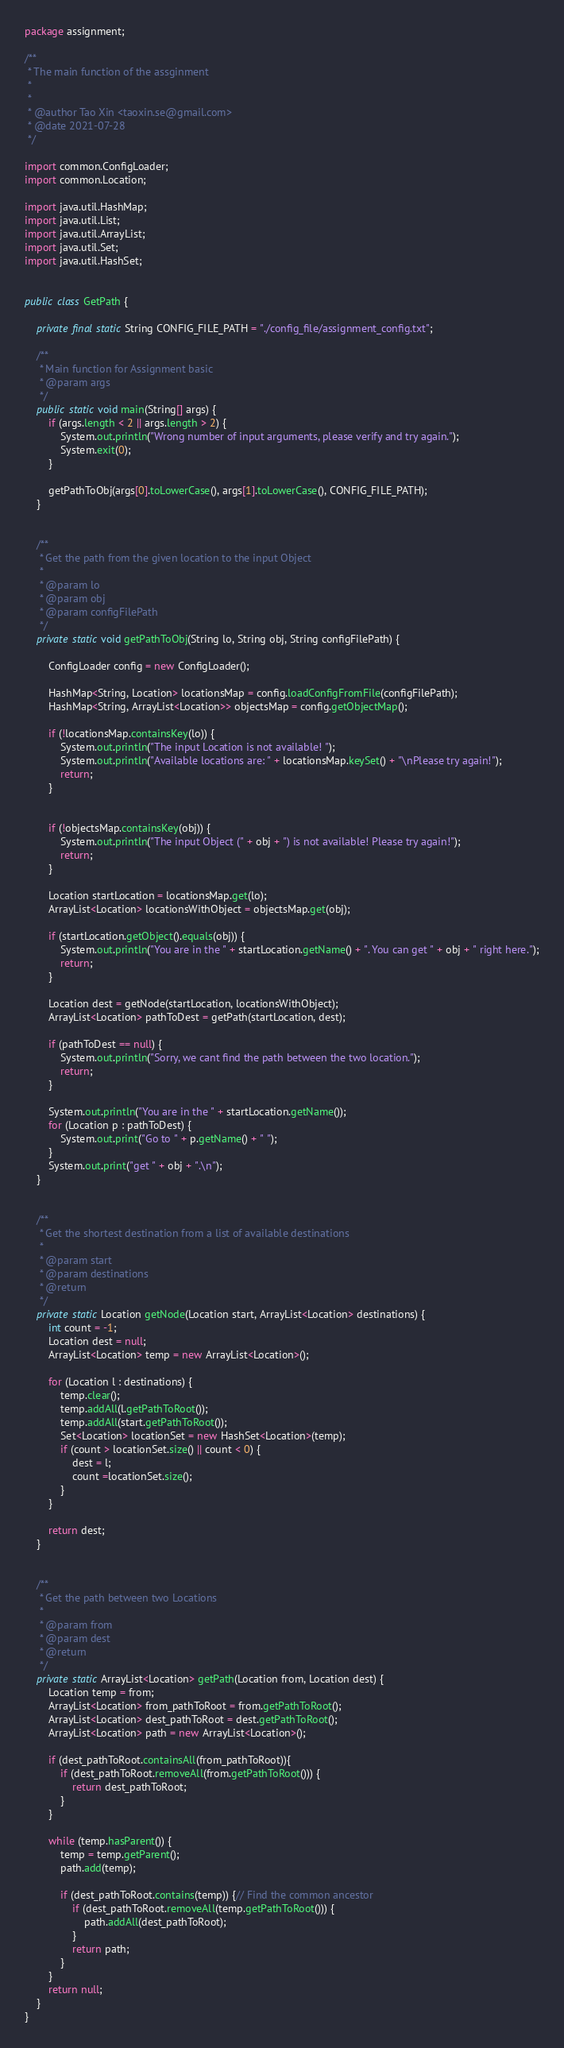<code> <loc_0><loc_0><loc_500><loc_500><_Java_>package assignment;

/**
 * The main function of the assginment
 *
 *
 * @author Tao Xin <taoxin.se@gmail.com>
 * @date 2021-07-28
 */

import common.ConfigLoader;
import common.Location;

import java.util.HashMap;
import java.util.List;
import java.util.ArrayList;
import java.util.Set;
import java.util.HashSet;


public class GetPath {

    private final static String CONFIG_FILE_PATH = "./config_file/assignment_config.txt";

    /**
     * Main function for Assignment basic
     * @param args
     */
    public static void main(String[] args) {
        if (args.length < 2 || args.length > 2) {
            System.out.println("Wrong number of input arguments, please verify and try again.");
            System.exit(0);
        }

        getPathToObj(args[0].toLowerCase(), args[1].toLowerCase(), CONFIG_FILE_PATH);
    }


    /**
     * Get the path from the given location to the input Object
     *
     * @param lo
     * @param obj
     * @param configFilePath
     */
    private static void getPathToObj(String lo, String obj, String configFilePath) {

        ConfigLoader config = new ConfigLoader();

        HashMap<String, Location> locationsMap = config.loadConfigFromFile(configFilePath);
        HashMap<String, ArrayList<Location>> objectsMap = config.getObjectMap();

        if (!locationsMap.containsKey(lo)) {
            System.out.println("The input Location is not available! ");
            System.out.println("Available locations are: " + locationsMap.keySet() + "\nPlease try again!");
            return;
        }


        if (!objectsMap.containsKey(obj)) {
            System.out.println("The input Object (" + obj + ") is not available! Please try again!");
            return;
        }

        Location startLocation = locationsMap.get(lo);
        ArrayList<Location> locationsWithObject = objectsMap.get(obj);

        if (startLocation.getObject().equals(obj)) {
            System.out.println("You are in the " + startLocation.getName() + ". You can get " + obj + " right here.");
            return;
        }

        Location dest = getNode(startLocation, locationsWithObject);
        ArrayList<Location> pathToDest = getPath(startLocation, dest);

        if (pathToDest == null) {
            System.out.println("Sorry, we cant find the path between the two location.");
            return;
        }

        System.out.println("You are in the " + startLocation.getName());
        for (Location p : pathToDest) {
            System.out.print("Go to " + p.getName() + " ");
        }
        System.out.print("get " + obj + ".\n");
    }


    /**
     * Get the shortest destination from a list of available destinations
     *
     * @param start
     * @param destinations
     * @return
     */
    private static Location getNode(Location start, ArrayList<Location> destinations) {
        int count = -1;
        Location dest = null;
        ArrayList<Location> temp = new ArrayList<Location>();

        for (Location l : destinations) {
            temp.clear();
            temp.addAll(l.getPathToRoot());
            temp.addAll(start.getPathToRoot());
            Set<Location> locationSet = new HashSet<Location>(temp);
            if (count > locationSet.size() || count < 0) {
                dest = l;
                count =locationSet.size();
            }
        }

        return dest;
    }


    /**
     * Get the path between two Locations
     *
     * @param from
     * @param dest
     * @return
     */
    private static ArrayList<Location> getPath(Location from, Location dest) {
        Location temp = from;
        ArrayList<Location> from_pathToRoot = from.getPathToRoot();
        ArrayList<Location> dest_pathToRoot = dest.getPathToRoot();
        ArrayList<Location> path = new ArrayList<Location>();

        if (dest_pathToRoot.containsAll(from_pathToRoot)){
            if (dest_pathToRoot.removeAll(from.getPathToRoot())) {
                return dest_pathToRoot;
            }
        }

        while (temp.hasParent()) {
            temp = temp.getParent();
            path.add(temp);

            if (dest_pathToRoot.contains(temp)) {// Find the common ancestor
                if (dest_pathToRoot.removeAll(temp.getPathToRoot())) {
                    path.addAll(dest_pathToRoot);
                }
                return path;
            }
        }
        return null;
    }
}</code> 